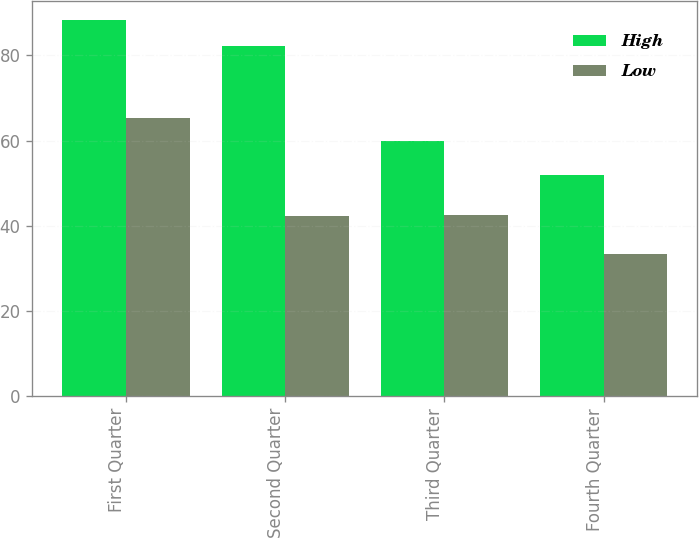Convert chart to OTSL. <chart><loc_0><loc_0><loc_500><loc_500><stacked_bar_chart><ecel><fcel>First Quarter<fcel>Second Quarter<fcel>Third Quarter<fcel>Fourth Quarter<nl><fcel>High<fcel>88.35<fcel>82.25<fcel>60<fcel>51.95<nl><fcel>Low<fcel>65.44<fcel>42.24<fcel>42.67<fcel>33.3<nl></chart> 